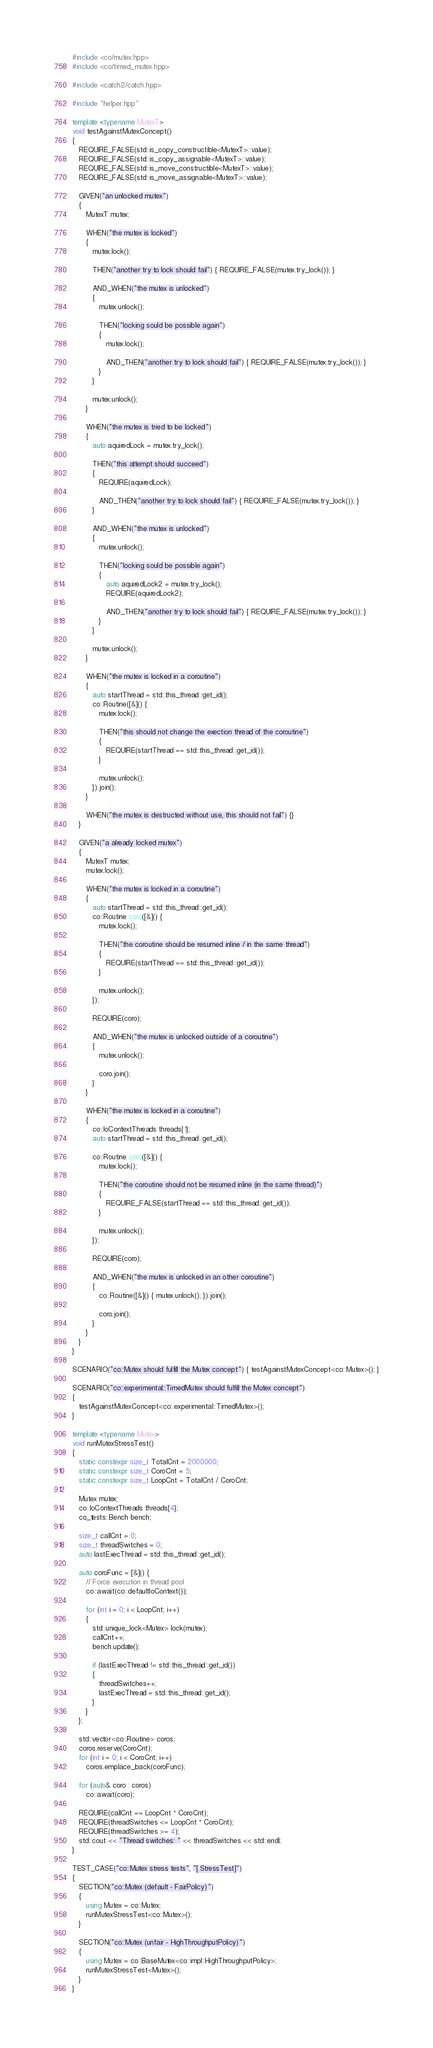<code> <loc_0><loc_0><loc_500><loc_500><_C++_>#include <co/mutex.hpp>
#include <co/timed_mutex.hpp>

#include <catch2/catch.hpp>

#include "helper.hpp"

template <typename MutexT>
void testAgainstMutexConcept()
{
   REQUIRE_FALSE(std::is_copy_constructible<MutexT>::value);
   REQUIRE_FALSE(std::is_copy_assignable<MutexT>::value);
   REQUIRE_FALSE(std::is_move_constructible<MutexT>::value);
   REQUIRE_FALSE(std::is_move_assignable<MutexT>::value);

   GIVEN("an unlocked mutex")
   {
      MutexT mutex;

      WHEN("the mutex is locked")
      {
         mutex.lock();

         THEN("another try to lock should fail") { REQUIRE_FALSE(mutex.try_lock()); }

         AND_WHEN("the mutex is unlocked")
         {
            mutex.unlock();

            THEN("locking sould be possible again")
            {
               mutex.lock();

               AND_THEN("another try to lock should fail") { REQUIRE_FALSE(mutex.try_lock()); }
            }
         }

         mutex.unlock();
      }

      WHEN("the mutex is tried to be locked")
      {
         auto aquiredLock = mutex.try_lock();

         THEN("this attempt should succeed")
         {
            REQUIRE(aquiredLock);

            AND_THEN("another try to lock should fail") { REQUIRE_FALSE(mutex.try_lock()); }
         }

         AND_WHEN("the mutex is unlocked")
         {
            mutex.unlock();

            THEN("locking sould be possible again")
            {
               auto aquiredLock2 = mutex.try_lock();
               REQUIRE(aquiredLock2);

               AND_THEN("another try to lock should fail") { REQUIRE_FALSE(mutex.try_lock()); }
            }
         }

         mutex.unlock();
      }

      WHEN("the mutex is locked in a coroutine")
      {
         auto startThread = std::this_thread::get_id();
         co::Routine([&]() {
            mutex.lock();

            THEN("this should not change the exection thread of the coroutine")
            {
               REQUIRE(startThread == std::this_thread::get_id());
            }

            mutex.unlock();
         }).join();
      }

      WHEN("the mutex is destructed without use, this should not fail") {}
   }

   GIVEN("a already locked mutex")
   {
      MutexT mutex;
      mutex.lock();

      WHEN("the mutex is locked in a coroutine")
      {
         auto startThread = std::this_thread::get_id();
         co::Routine coro([&]() {
            mutex.lock();

            THEN("the coroutine should be resumed inline / in the same thread")
            {
               REQUIRE(startThread == std::this_thread::get_id());
            }

            mutex.unlock();
         });

         REQUIRE(coro);

         AND_WHEN("the mutex is unlocked outside of a coroutine")
         {
            mutex.unlock();

            coro.join();
         }
      }

      WHEN("the mutex is locked in a coroutine")
      {
         co::IoContextThreads threads{1};
         auto startThread = std::this_thread::get_id();

         co::Routine coro([&]() {
            mutex.lock();

            THEN("the coroutine should not be resumed inline (in the same thread)")
            {
               REQUIRE_FALSE(startThread == std::this_thread::get_id());
            }

            mutex.unlock();
         });

         REQUIRE(coro);

         AND_WHEN("the mutex is unlocked in an other coroutine")
         {
            co::Routine([&]() { mutex.unlock(); }).join();

            coro.join();
         }
      }
   }
}

SCENARIO("co::Mutex should fulfill the Mutex concept") { testAgainstMutexConcept<co::Mutex>(); }

SCENARIO("co::experimental::TimedMutex should fulfill the Mutex concept")
{
   testAgainstMutexConcept<co::experimental::TimedMutex>();
}

template <typename Mutex>
void runMutexStressTest()
{
   static constexpr size_t TotalCnt = 2000000;
   static constexpr size_t CoroCnt = 5;
   static constexpr size_t LoopCnt = TotalCnt / CoroCnt;

   Mutex mutex;
   co::IoContextThreads threads{4};
   co_tests::Bench bench;

   size_t callCnt = 0;
   size_t threadSwitches = 0;
   auto lastExecThread = std::this_thread::get_id();

   auto coroFunc = [&]() {
      // Force execution in thread pool
      co::await(co::defaultIoContext());

      for (int i = 0; i < LoopCnt; i++)
      {
         std::unique_lock<Mutex> lock(mutex);
         callCnt++;
         bench.update();

         if (lastExecThread != std::this_thread::get_id())
         {
            threadSwitches++;
            lastExecThread = std::this_thread::get_id();
         }
      }
   };

   std::vector<co::Routine> coros;
   coros.reserve(CoroCnt);
   for (int i = 0; i < CoroCnt; i++)
      coros.emplace_back(coroFunc);

   for (auto& coro : coros)
      co::await(coro);

   REQUIRE(callCnt == LoopCnt * CoroCnt);
   REQUIRE(threadSwitches <= LoopCnt * CoroCnt);
   REQUIRE(threadSwitches >= 4);
   std::cout << "Thread switches: " << threadSwitches << std::endl;
}

TEST_CASE("co::Mutex stress tests", "[.StressTest]")
{
   SECTION("co::Mutex (default - FairPolicy)")
   {
      using Mutex = co::Mutex;
      runMutexStressTest<co::Mutex>();
   }

   SECTION("co::Mutex (unfair - HighThroughputPolicy)")
   {
      using Mutex = co::BaseMutex<co::impl::HighThroughputPolicy>;
      runMutexStressTest<Mutex>();
   }
}
</code> 